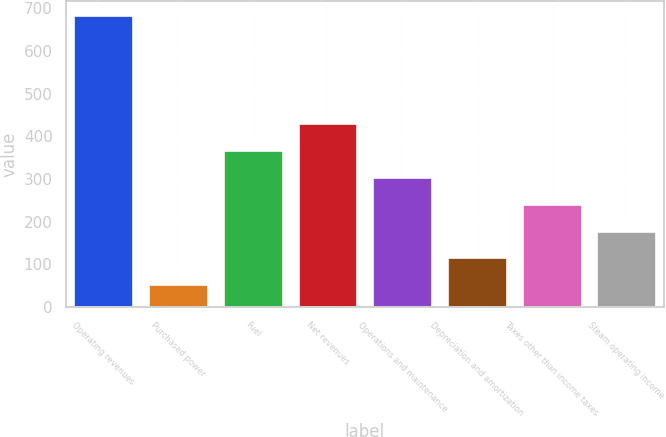Convert chart to OTSL. <chart><loc_0><loc_0><loc_500><loc_500><bar_chart><fcel>Operating revenues<fcel>Purchased power<fcel>Fuel<fcel>Net revenues<fcel>Operations and maintenance<fcel>Depreciation and amortization<fcel>Taxes other than income taxes<fcel>Steam operating income<nl><fcel>683<fcel>53<fcel>368<fcel>431<fcel>305<fcel>116<fcel>242<fcel>179<nl></chart> 